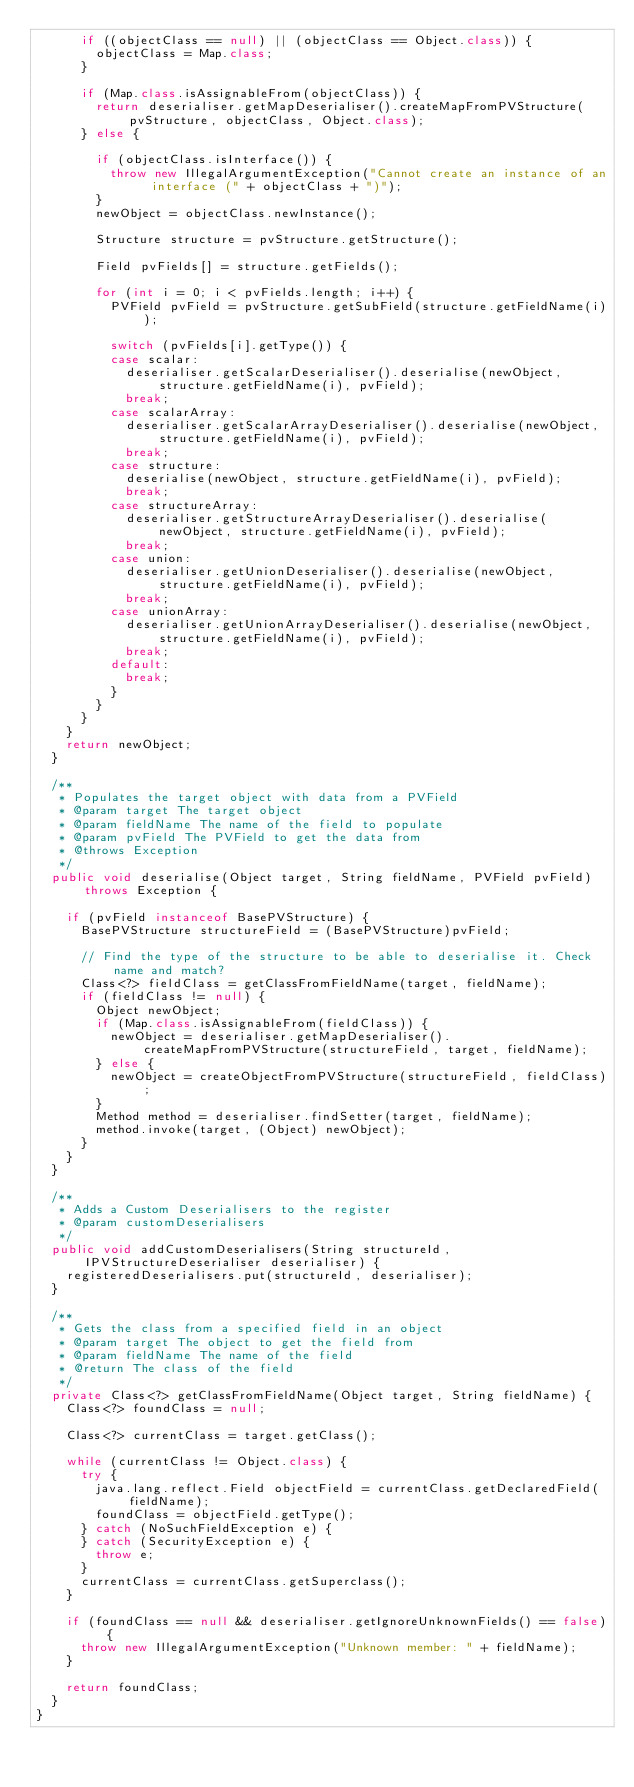Convert code to text. <code><loc_0><loc_0><loc_500><loc_500><_Java_>			if ((objectClass == null) || (objectClass == Object.class)) {
				objectClass = Map.class;
			}
		
			if (Map.class.isAssignableFrom(objectClass)) {
				return deserialiser.getMapDeserialiser().createMapFromPVStructure(pvStructure, objectClass, Object.class);
			} else {
			
				if (objectClass.isInterface()) {
					throw new IllegalArgumentException("Cannot create an instance of an interface (" + objectClass + ")");
				}
				newObject = objectClass.newInstance();
				
				Structure structure = pvStructure.getStructure();
				
				Field pvFields[] = structure.getFields();
				
				for (int i = 0; i < pvFields.length; i++) {					
					PVField pvField = pvStructure.getSubField(structure.getFieldName(i));
					
					switch (pvFields[i].getType()) {
					case scalar:
						deserialiser.getScalarDeserialiser().deserialise(newObject, structure.getFieldName(i), pvField);
						break;
					case scalarArray:
						deserialiser.getScalarArrayDeserialiser().deserialise(newObject, structure.getFieldName(i), pvField);
						break;
					case structure:
						deserialise(newObject, structure.getFieldName(i), pvField);
						break;
					case structureArray:
						deserialiser.getStructureArrayDeserialiser().deserialise(newObject, structure.getFieldName(i), pvField);
						break;
					case union:
						deserialiser.getUnionDeserialiser().deserialise(newObject, structure.getFieldName(i), pvField);
						break;
					case unionArray:
						deserialiser.getUnionArrayDeserialiser().deserialise(newObject, structure.getFieldName(i), pvField);
						break;
					default:
						break;
					}
				}
			}
		}
		return newObject;
	}
	
	/**
	 * Populates the target object with data from a PVField
	 * @param target The target object
	 * @param fieldName The name of the field to populate
	 * @param pvField The PVField to get the data from
	 * @throws Exception
	 */
	public void deserialise(Object target, String fieldName, PVField pvField) throws Exception {
		
		if (pvField instanceof BasePVStructure) {
			BasePVStructure structureField = (BasePVStructure)pvField;
			
			// Find the type of the structure to be able to deserialise it. Check name and match?
			Class<?> fieldClass = getClassFromFieldName(target, fieldName);
			if (fieldClass != null) {
				Object newObject;
				if (Map.class.isAssignableFrom(fieldClass)) {
					newObject = deserialiser.getMapDeserialiser().createMapFromPVStructure(structureField, target, fieldName);
				} else {
					newObject = createObjectFromPVStructure(structureField, fieldClass);
				}
				Method method = deserialiser.findSetter(target, fieldName);
				method.invoke(target, (Object) newObject);
			}
		}
	}
	
	/**
	 * Adds a Custom Deserialisers to the register
	 * @param customDeserialisers
	 */
	public void addCustomDeserialisers(String structureId, IPVStructureDeserialiser deserialiser) {
		registeredDeserialisers.put(structureId, deserialiser);
	}
	
	/**
	 * Gets the class from a specified field in an object
	 * @param target The object to get the field from
	 * @param fieldName The name of the field
	 * @return The class of the field
	 */
	private Class<?> getClassFromFieldName(Object target, String fieldName) {
		Class<?> foundClass = null;
		
		Class<?> currentClass = target.getClass();
		
		while (currentClass != Object.class) {
			try {
				java.lang.reflect.Field objectField = currentClass.getDeclaredField(fieldName);
				foundClass = objectField.getType();
			} catch (NoSuchFieldException e) {
			} catch (SecurityException e) {
				throw e;
			}
			currentClass = currentClass.getSuperclass();
		}

		if (foundClass == null && deserialiser.getIgnoreUnknownFields() == false) {
			throw new IllegalArgumentException("Unknown member: " + fieldName);
		}
		
		return foundClass;
	}
}
</code> 